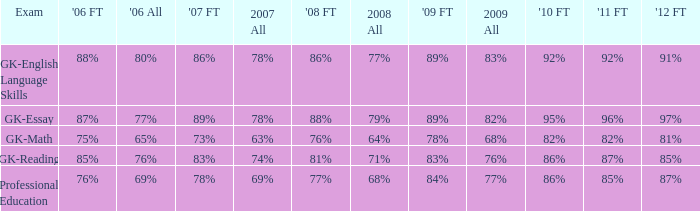What is the percentage for all in 2008 when all in 2007 was 69%? 68%. 